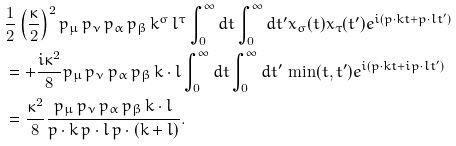Convert formula to latex. <formula><loc_0><loc_0><loc_500><loc_500>& \frac { 1 } { 2 } \left ( \frac { \kappa } { 2 } \right ) ^ { 2 } p _ { \mu } \, p _ { \nu } \, p _ { \alpha } \, p _ { \beta } \, k ^ { \sigma } \, l ^ { \tau } \int _ { 0 } ^ { \infty } d t \int _ { 0 } ^ { \infty } d t ^ { \prime } x _ { \sigma } ( t ) x _ { \tau } ( t ^ { \prime } ) e ^ { i ( p \cdot k t + p \cdot l t ^ { \prime } ) } \\ & = + \frac { i \kappa ^ { 2 } } { 8 } p _ { \mu } \, p _ { \nu } \, p _ { \alpha } \, p _ { \beta } \, k \cdot l \int _ { 0 } ^ { \infty } d t \int _ { 0 } ^ { \infty } d t ^ { \prime } \, \min ( t , t ^ { \prime } ) e ^ { i ( p \cdot k t + i p \cdot l t ^ { \prime } ) } \\ & = \frac { \kappa ^ { 2 } } { 8 } \frac { p _ { \mu } \, p _ { \nu } \, p _ { \alpha } \, p _ { \beta } \, k \cdot l } { p \cdot k \, p \cdot l \, p \cdot ( k + l ) } .</formula> 